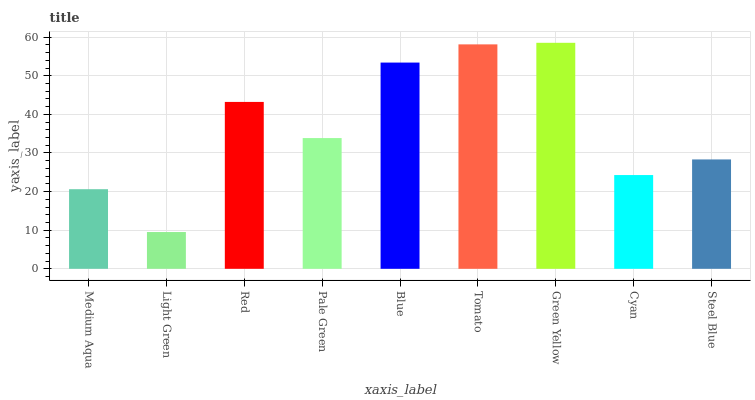Is Light Green the minimum?
Answer yes or no. Yes. Is Green Yellow the maximum?
Answer yes or no. Yes. Is Red the minimum?
Answer yes or no. No. Is Red the maximum?
Answer yes or no. No. Is Red greater than Light Green?
Answer yes or no. Yes. Is Light Green less than Red?
Answer yes or no. Yes. Is Light Green greater than Red?
Answer yes or no. No. Is Red less than Light Green?
Answer yes or no. No. Is Pale Green the high median?
Answer yes or no. Yes. Is Pale Green the low median?
Answer yes or no. Yes. Is Cyan the high median?
Answer yes or no. No. Is Red the low median?
Answer yes or no. No. 